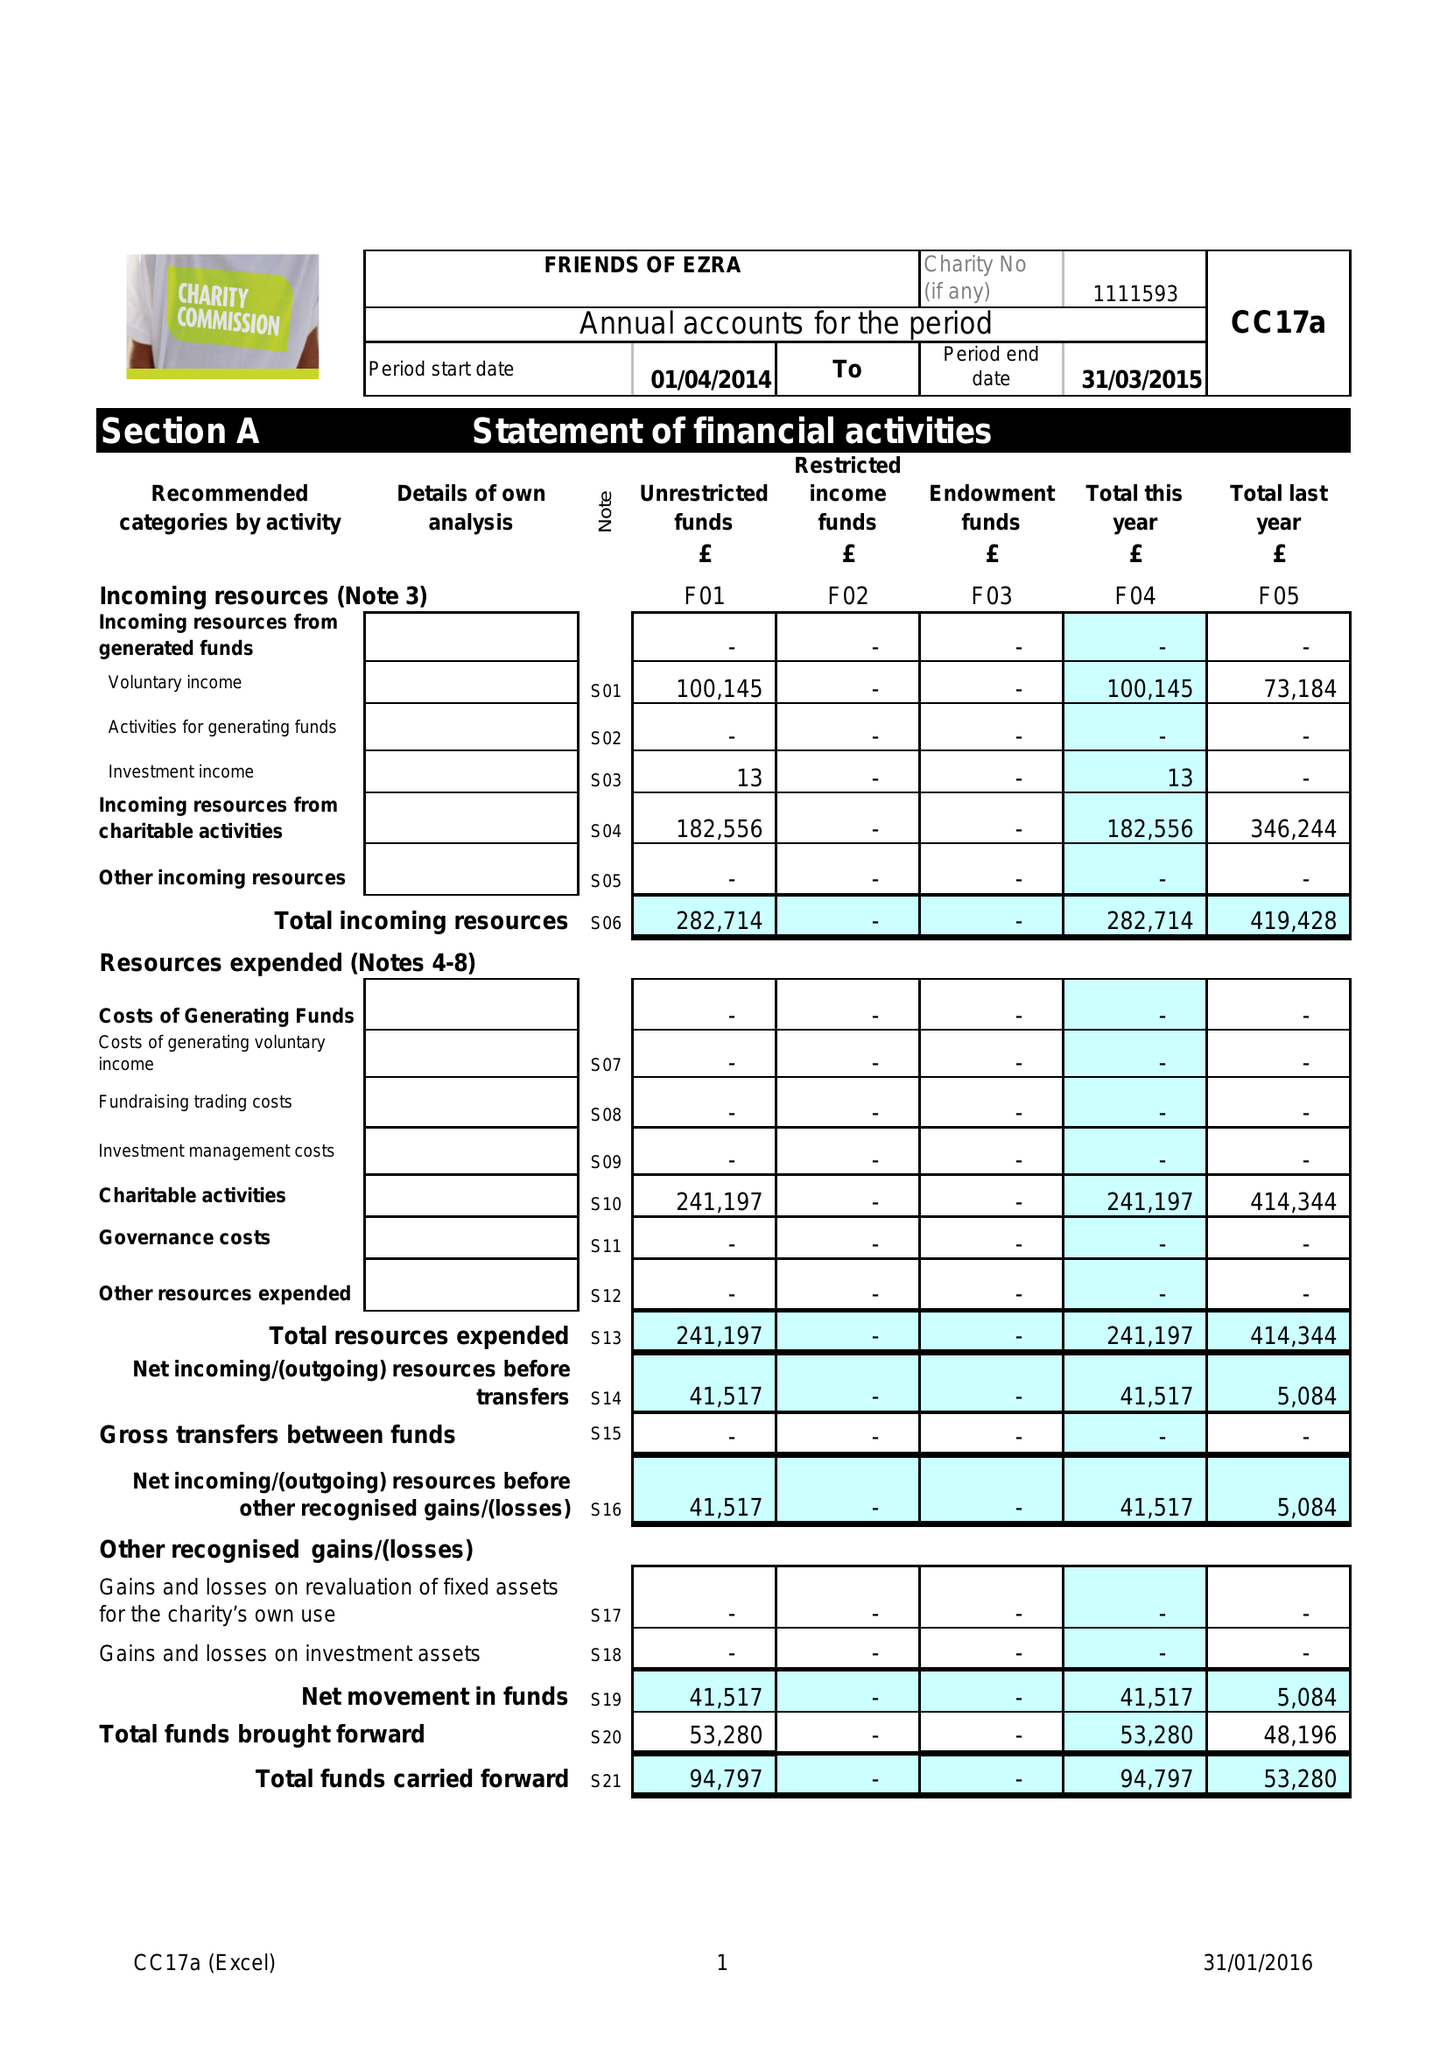What is the value for the spending_annually_in_british_pounds?
Answer the question using a single word or phrase. 241197.00 